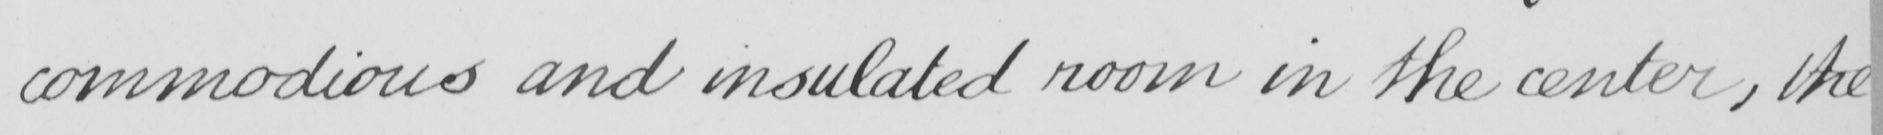What is written in this line of handwriting? commodious and insulated room in the center , the 